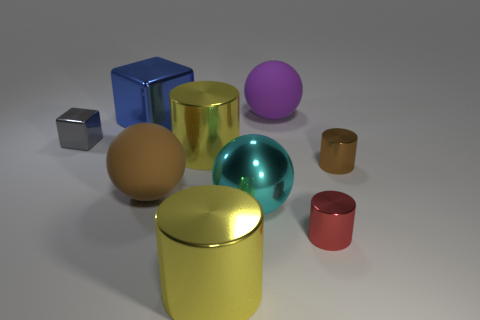Subtract all big rubber balls. How many balls are left? 1 Subtract 1 cylinders. How many cylinders are left? 3 Subtract all purple cylinders. Subtract all purple spheres. How many cylinders are left? 4 Subtract all balls. How many objects are left? 6 Add 5 blue cubes. How many blue cubes exist? 6 Subtract 1 red cylinders. How many objects are left? 8 Subtract all blue things. Subtract all cyan spheres. How many objects are left? 7 Add 2 yellow metal things. How many yellow metal things are left? 4 